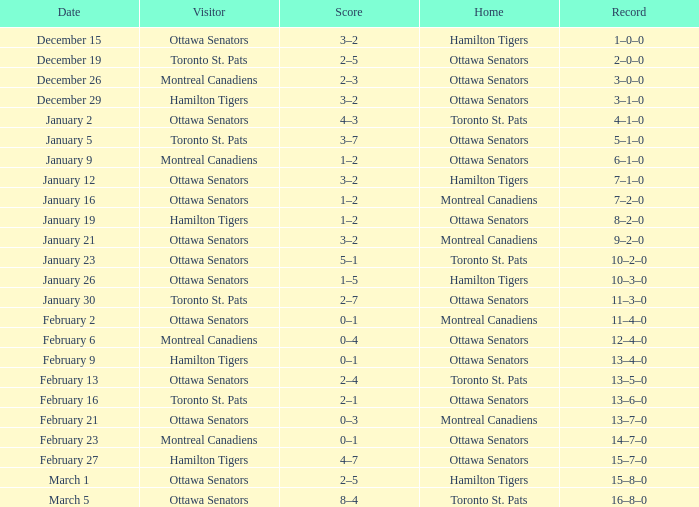On january 12, what was the numerical outcome? 3–2. 